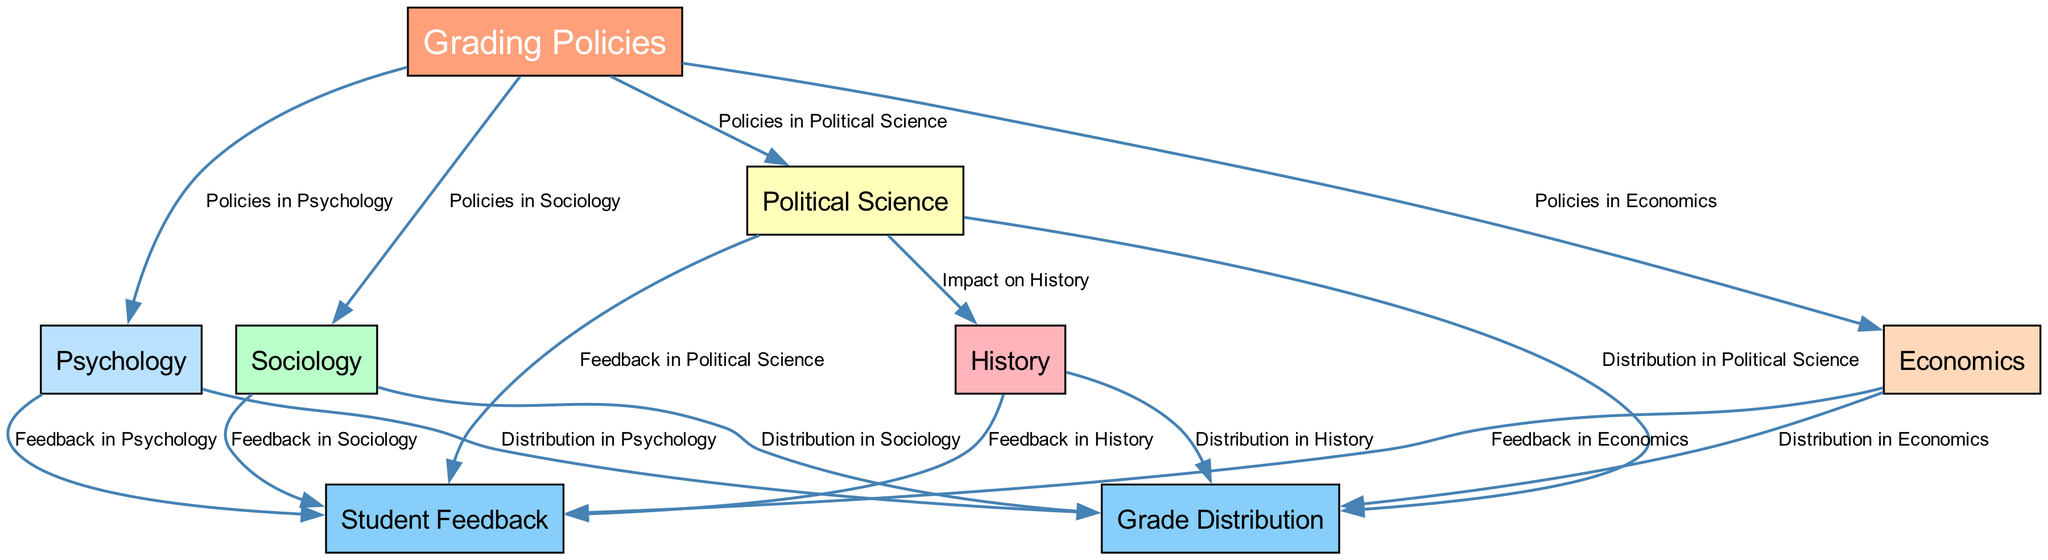What are the five disciplines represented in the diagram? The diagram includes nodes for Sociology, Psychology, Political Science, Economics, and History, which are the five distinct social science disciplines depicted.
Answer: Sociology, Psychology, Political Science, Economics, History What color represents "Grading Policies"? "Grading Policies" is visually represented using a light coral color, specifically coded as #FFA07A, which differentiates it from other nodes.
Answer: Light coral How many feedback nodes are in the diagram? The diagram has a total of five feedback nodes corresponding to each discipline - Sociology, Psychology, Political Science, Economics, and History - thus making it five feedback nodes in total.
Answer: Five Which discipline connects to History and what relationship is represented? Political Science connects to History with the labeled relationship “Impact on History,” indicating a flow of influence from Political Science to History in the grading policies context.
Answer: Political Science, Impact on History Which discipline has the most outgoing edges to Grade Distribution? All five disciplines (Sociology, Psychology, Political Science, Economics, History) have an edge pointing to Grade Distribution, showing that they all contribute to this aspect equally.
Answer: All five What is the connection between Sociology and Student Feedback? The connection from Sociology to Student Feedback is labeled “Feedback in Sociology,” indicating that there is a flow from the discipline of Sociology to the feedback mechanism that assesses its grading policy.
Answer: Feedback in Sociology How many nodes are there in total in the diagram? Upon counting, there are a total of eight nodes in the diagram, which includes both disciplines, grading policies, grade distribution, and student feedback aspects.
Answer: Eight Which discipline is linked to the fewest edges in terms of feedback and distribution? Each discipline has one outgoing edge leading to both Grade Distribution and Student Feedback; therefore, no discipline can be identified as having fewer connections since they are all equal in this context.
Answer: All equal Which node is the central focus of the diagram? The central node is “Grading Policies,” as it connects to each discipline and is the starting point for understanding the relationships depicted in the diagram.
Answer: Grading Policies 